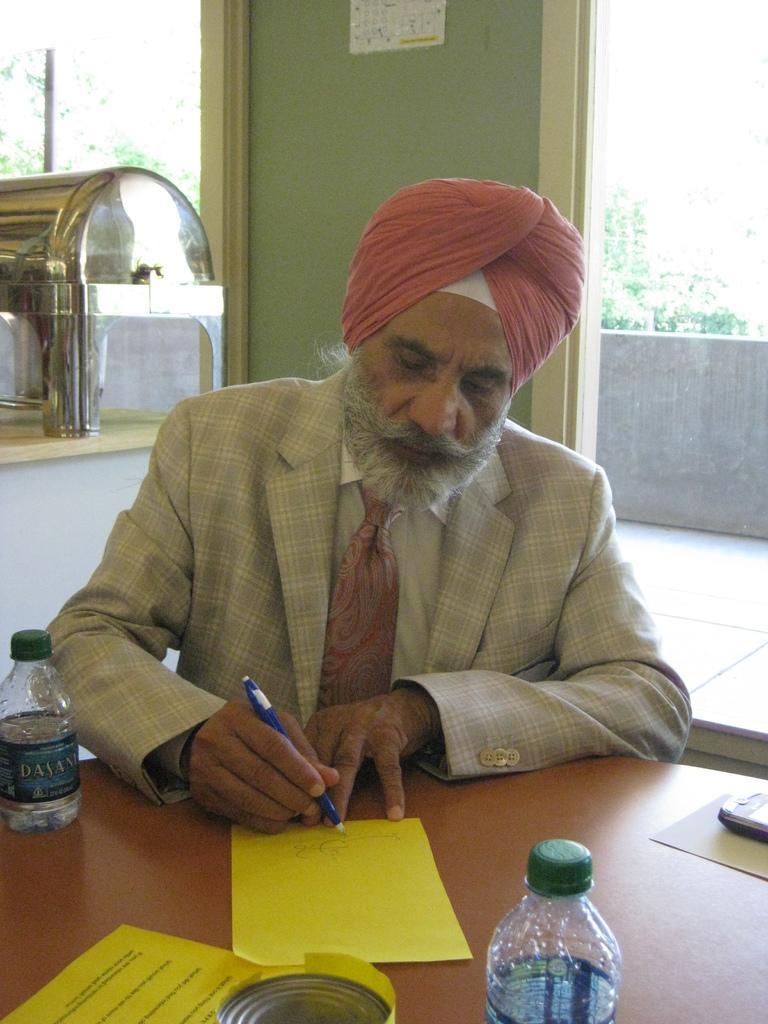In one or two sentences, can you explain what this image depicts? This person wore suit and sitting on a chair. In-front of this person there is a table, on a table there is a paper and bottle. This person is holding a pen. These are trees. On this table there is a container. 